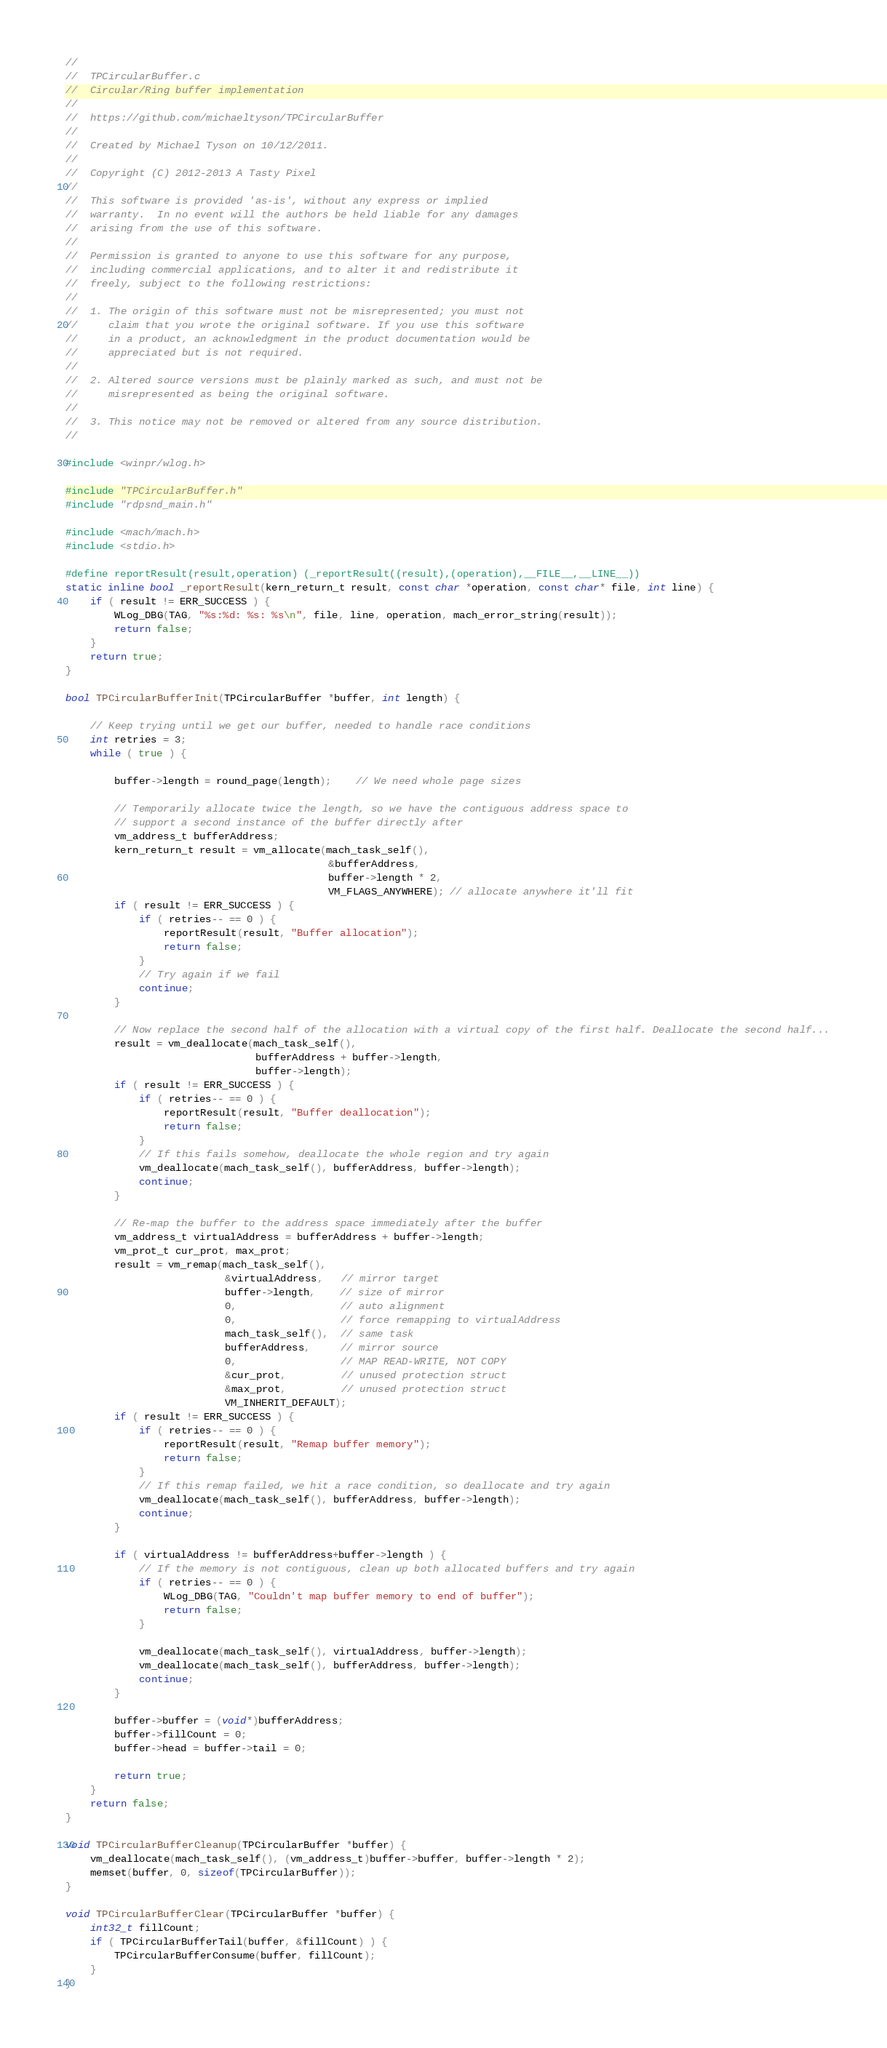<code> <loc_0><loc_0><loc_500><loc_500><_C_>//
//  TPCircularBuffer.c
//  Circular/Ring buffer implementation
//
//  https://github.com/michaeltyson/TPCircularBuffer
//
//  Created by Michael Tyson on 10/12/2011.
//
//  Copyright (C) 2012-2013 A Tasty Pixel
//
//  This software is provided 'as-is', without any express or implied
//  warranty.  In no event will the authors be held liable for any damages
//  arising from the use of this software.
//
//  Permission is granted to anyone to use this software for any purpose,
//  including commercial applications, and to alter it and redistribute it
//  freely, subject to the following restrictions:
//
//  1. The origin of this software must not be misrepresented; you must not
//     claim that you wrote the original software. If you use this software
//     in a product, an acknowledgment in the product documentation would be
//     appreciated but is not required.
//
//  2. Altered source versions must be plainly marked as such, and must not be
//     misrepresented as being the original software.
//
//  3. This notice may not be removed or altered from any source distribution.
//

#include <winpr/wlog.h>

#include "TPCircularBuffer.h"
#include "rdpsnd_main.h"

#include <mach/mach.h>
#include <stdio.h>

#define reportResult(result,operation) (_reportResult((result),(operation),__FILE__,__LINE__))
static inline bool _reportResult(kern_return_t result, const char *operation, const char* file, int line) {
    if ( result != ERR_SUCCESS ) {
        WLog_DBG(TAG, "%s:%d: %s: %s\n", file, line, operation, mach_error_string(result));
        return false;
    }
    return true;
}

bool TPCircularBufferInit(TPCircularBuffer *buffer, int length) {

    // Keep trying until we get our buffer, needed to handle race conditions
    int retries = 3;
    while ( true ) {

        buffer->length = round_page(length);    // We need whole page sizes

        // Temporarily allocate twice the length, so we have the contiguous address space to
        // support a second instance of the buffer directly after
        vm_address_t bufferAddress;
        kern_return_t result = vm_allocate(mach_task_self(),
                                           &bufferAddress,
                                           buffer->length * 2,
                                           VM_FLAGS_ANYWHERE); // allocate anywhere it'll fit
        if ( result != ERR_SUCCESS ) {
            if ( retries-- == 0 ) {
                reportResult(result, "Buffer allocation");
                return false;
            }
            // Try again if we fail
            continue;
        }
        
        // Now replace the second half of the allocation with a virtual copy of the first half. Deallocate the second half...
        result = vm_deallocate(mach_task_self(),
                               bufferAddress + buffer->length,
                               buffer->length);
        if ( result != ERR_SUCCESS ) {
            if ( retries-- == 0 ) {
                reportResult(result, "Buffer deallocation");
                return false;
            }
            // If this fails somehow, deallocate the whole region and try again
            vm_deallocate(mach_task_self(), bufferAddress, buffer->length);
            continue;
        }
        
        // Re-map the buffer to the address space immediately after the buffer
        vm_address_t virtualAddress = bufferAddress + buffer->length;
        vm_prot_t cur_prot, max_prot;
        result = vm_remap(mach_task_self(),
                          &virtualAddress,   // mirror target
                          buffer->length,    // size of mirror
                          0,                 // auto alignment
                          0,                 // force remapping to virtualAddress
                          mach_task_self(),  // same task
                          bufferAddress,     // mirror source
                          0,                 // MAP READ-WRITE, NOT COPY
                          &cur_prot,         // unused protection struct
                          &max_prot,         // unused protection struct
                          VM_INHERIT_DEFAULT);
        if ( result != ERR_SUCCESS ) {
            if ( retries-- == 0 ) {
                reportResult(result, "Remap buffer memory");
                return false;
            }
            // If this remap failed, we hit a race condition, so deallocate and try again
            vm_deallocate(mach_task_self(), bufferAddress, buffer->length);
            continue;
        }
        
        if ( virtualAddress != bufferAddress+buffer->length ) {
            // If the memory is not contiguous, clean up both allocated buffers and try again
            if ( retries-- == 0 ) {
                WLog_DBG(TAG, "Couldn't map buffer memory to end of buffer");
                return false;
            }

            vm_deallocate(mach_task_self(), virtualAddress, buffer->length);
            vm_deallocate(mach_task_self(), bufferAddress, buffer->length);
            continue;
        }
        
        buffer->buffer = (void*)bufferAddress;
        buffer->fillCount = 0;
        buffer->head = buffer->tail = 0;
        
        return true;
    }
    return false;
}

void TPCircularBufferCleanup(TPCircularBuffer *buffer) {
    vm_deallocate(mach_task_self(), (vm_address_t)buffer->buffer, buffer->length * 2);
    memset(buffer, 0, sizeof(TPCircularBuffer));
}

void TPCircularBufferClear(TPCircularBuffer *buffer) {
    int32_t fillCount;
    if ( TPCircularBufferTail(buffer, &fillCount) ) {
        TPCircularBufferConsume(buffer, fillCount);
    }
}
</code> 